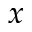Convert formula to latex. <formula><loc_0><loc_0><loc_500><loc_500>x</formula> 